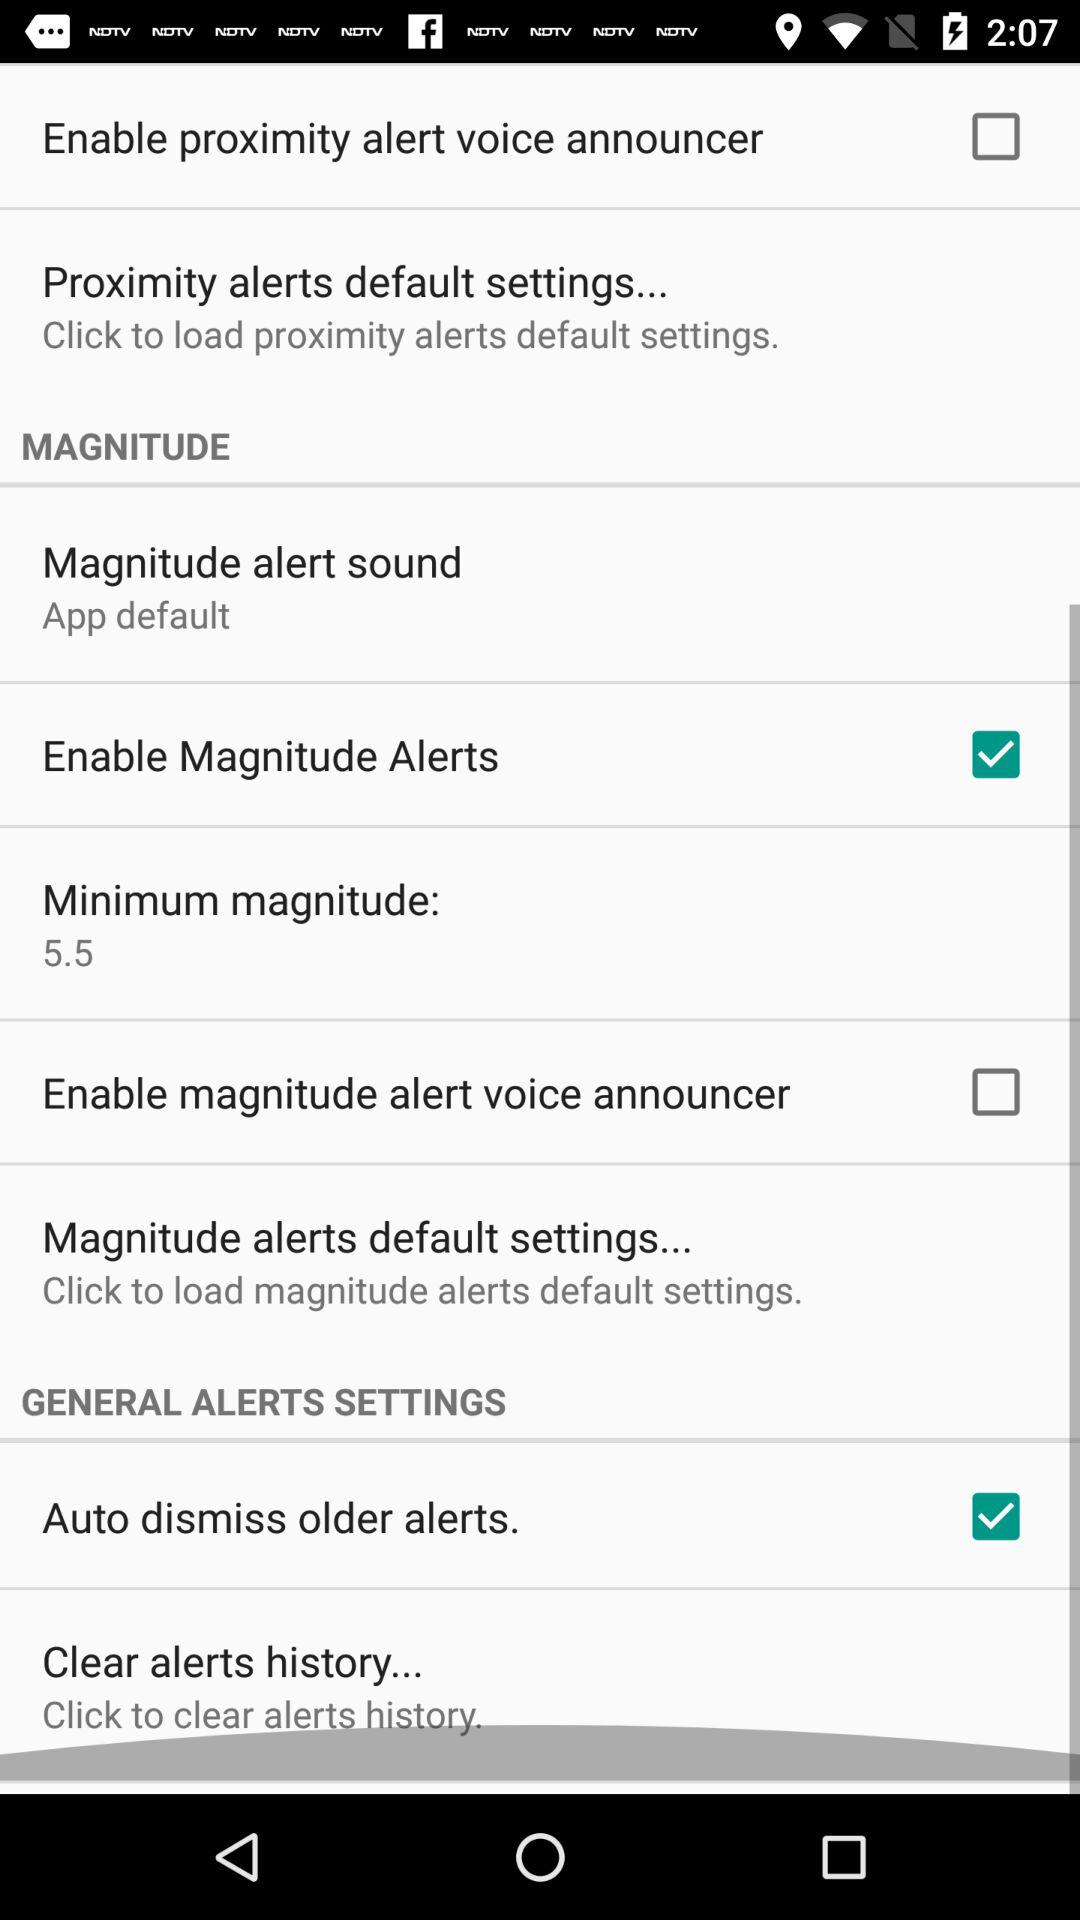What is the status of the "Enable proximity alert voice announcer"? The status is off. 